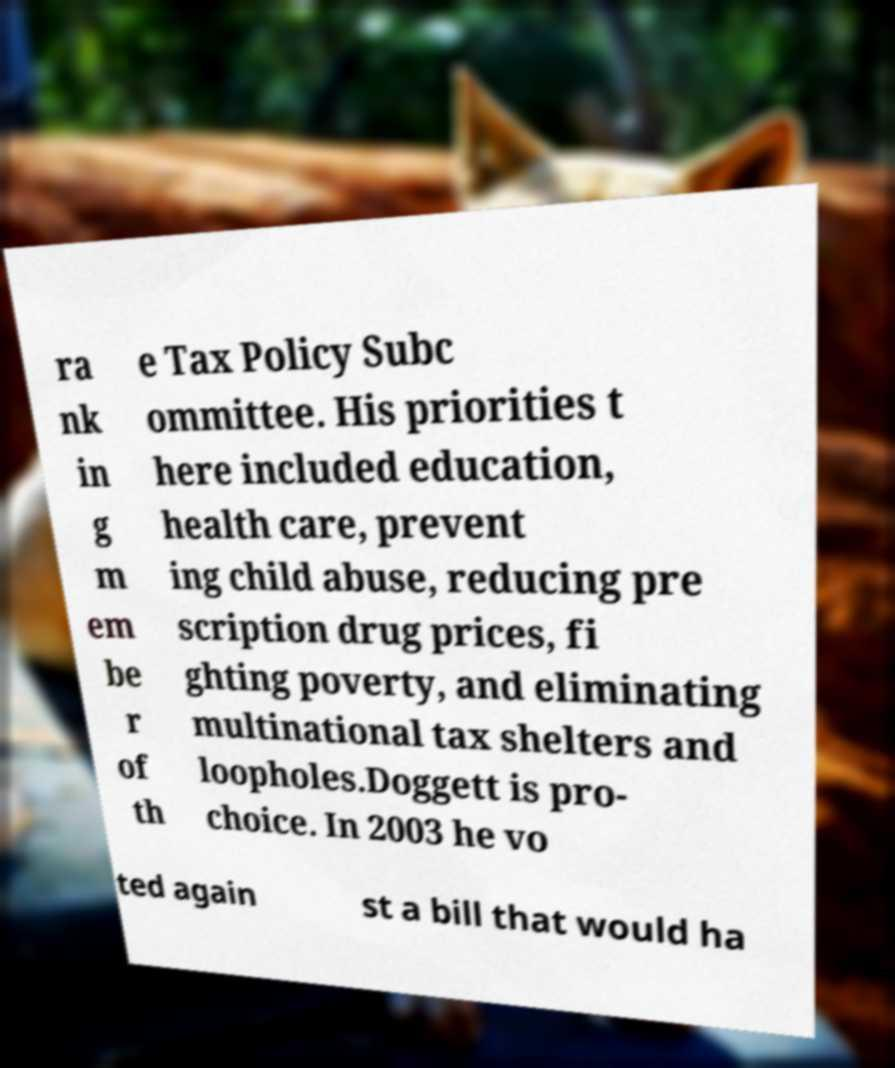Can you read and provide the text displayed in the image?This photo seems to have some interesting text. Can you extract and type it out for me? ra nk in g m em be r of th e Tax Policy Subc ommittee. His priorities t here included education, health care, prevent ing child abuse, reducing pre scription drug prices, fi ghting poverty, and eliminating multinational tax shelters and loopholes.Doggett is pro- choice. In 2003 he vo ted again st a bill that would ha 